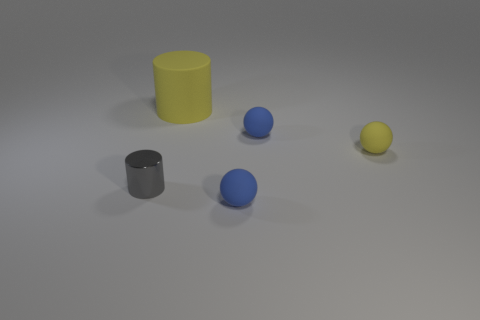Add 3 small rubber objects. How many objects exist? 8 Subtract all spheres. How many objects are left? 2 Add 1 small gray matte cubes. How many small gray matte cubes exist? 1 Subtract 0 yellow blocks. How many objects are left? 5 Subtract all big red shiny things. Subtract all small objects. How many objects are left? 1 Add 3 small blue balls. How many small blue balls are left? 5 